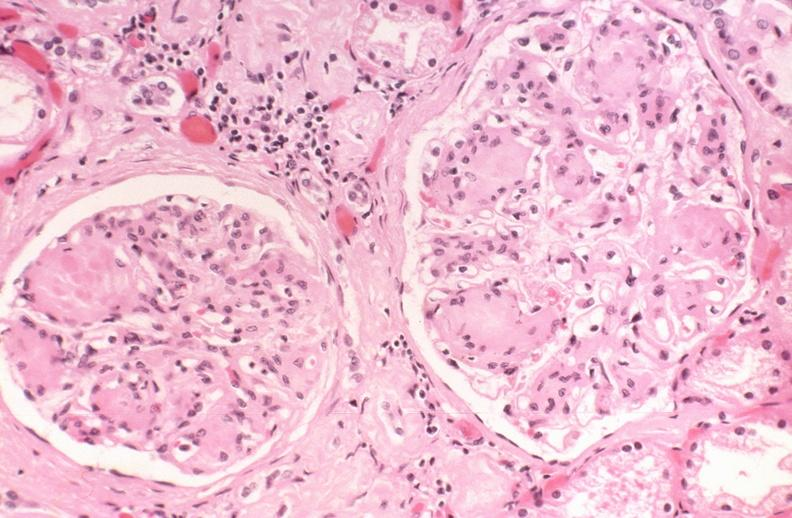where is this?
Answer the question using a single word or phrase. Urinary 